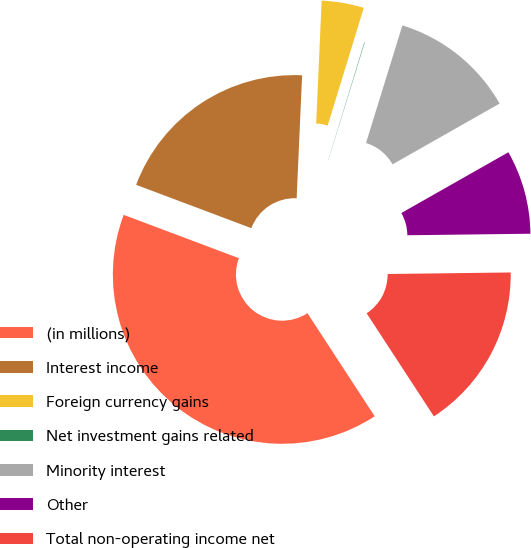Convert chart to OTSL. <chart><loc_0><loc_0><loc_500><loc_500><pie_chart><fcel>(in millions)<fcel>Interest income<fcel>Foreign currency gains<fcel>Net investment gains related<fcel>Minority interest<fcel>Other<fcel>Total non-operating income net<nl><fcel>39.93%<fcel>19.98%<fcel>4.03%<fcel>0.04%<fcel>12.01%<fcel>8.02%<fcel>16.0%<nl></chart> 